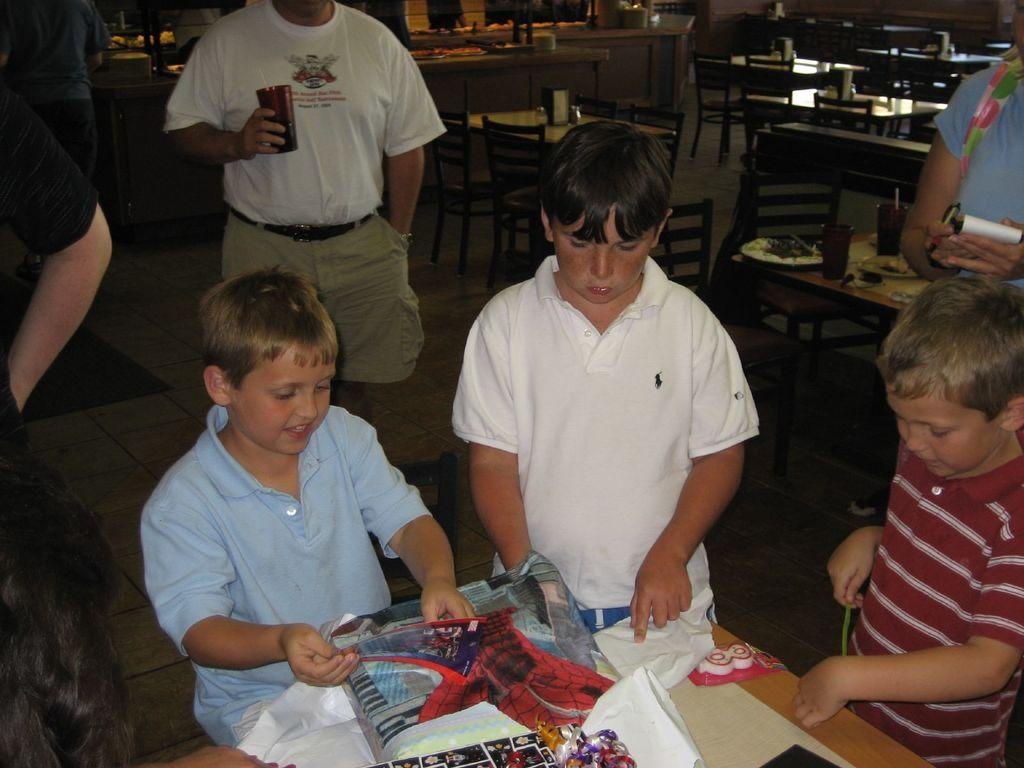What is happening in the image? There is a group of people standing in the image. What can be seen on the tables in the image? There are objects on the tables in the image. What is visible in the background of the image? There are chairs in the background of the image. What type of finger can be seen pointing at the objects on the tables in the image? There are no fingers visible in the image, let alone pointing at anything. 